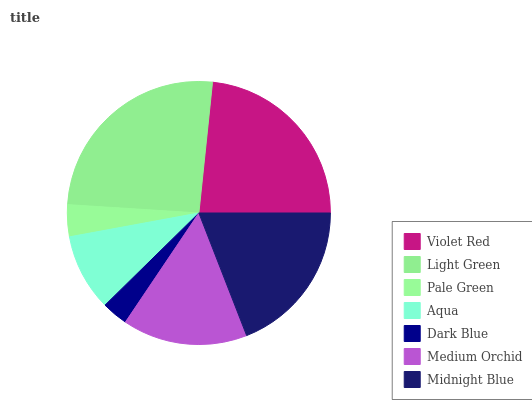Is Dark Blue the minimum?
Answer yes or no. Yes. Is Light Green the maximum?
Answer yes or no. Yes. Is Pale Green the minimum?
Answer yes or no. No. Is Pale Green the maximum?
Answer yes or no. No. Is Light Green greater than Pale Green?
Answer yes or no. Yes. Is Pale Green less than Light Green?
Answer yes or no. Yes. Is Pale Green greater than Light Green?
Answer yes or no. No. Is Light Green less than Pale Green?
Answer yes or no. No. Is Medium Orchid the high median?
Answer yes or no. Yes. Is Medium Orchid the low median?
Answer yes or no. Yes. Is Violet Red the high median?
Answer yes or no. No. Is Dark Blue the low median?
Answer yes or no. No. 